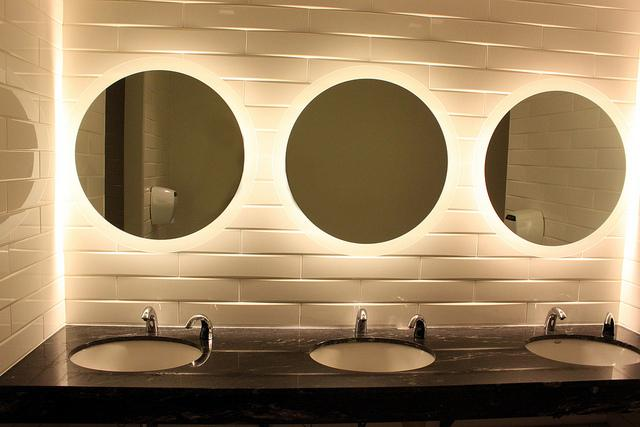How many sinks are on the row at this public bathroom area? Please explain your reasoning. three. There is one in the middle and two flanking it 